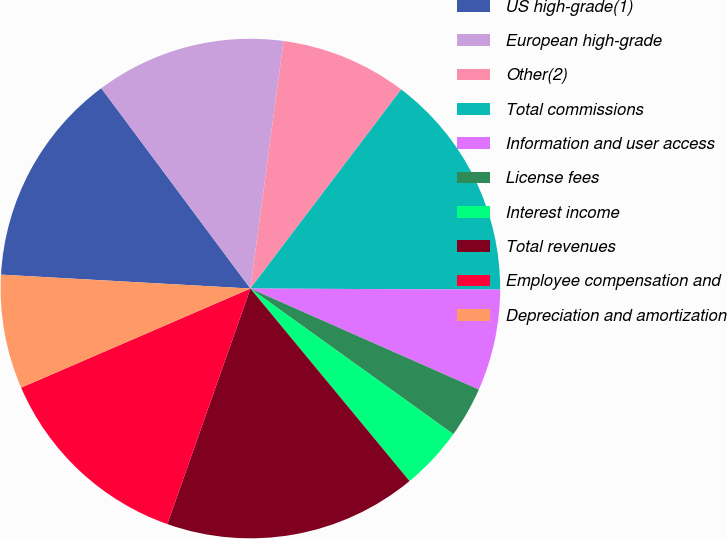Convert chart. <chart><loc_0><loc_0><loc_500><loc_500><pie_chart><fcel>US high-grade(1)<fcel>European high-grade<fcel>Other(2)<fcel>Total commissions<fcel>Information and user access<fcel>License fees<fcel>Interest income<fcel>Total revenues<fcel>Employee compensation and<fcel>Depreciation and amortization<nl><fcel>13.93%<fcel>12.3%<fcel>8.2%<fcel>14.75%<fcel>6.56%<fcel>3.28%<fcel>4.1%<fcel>16.39%<fcel>13.11%<fcel>7.38%<nl></chart> 